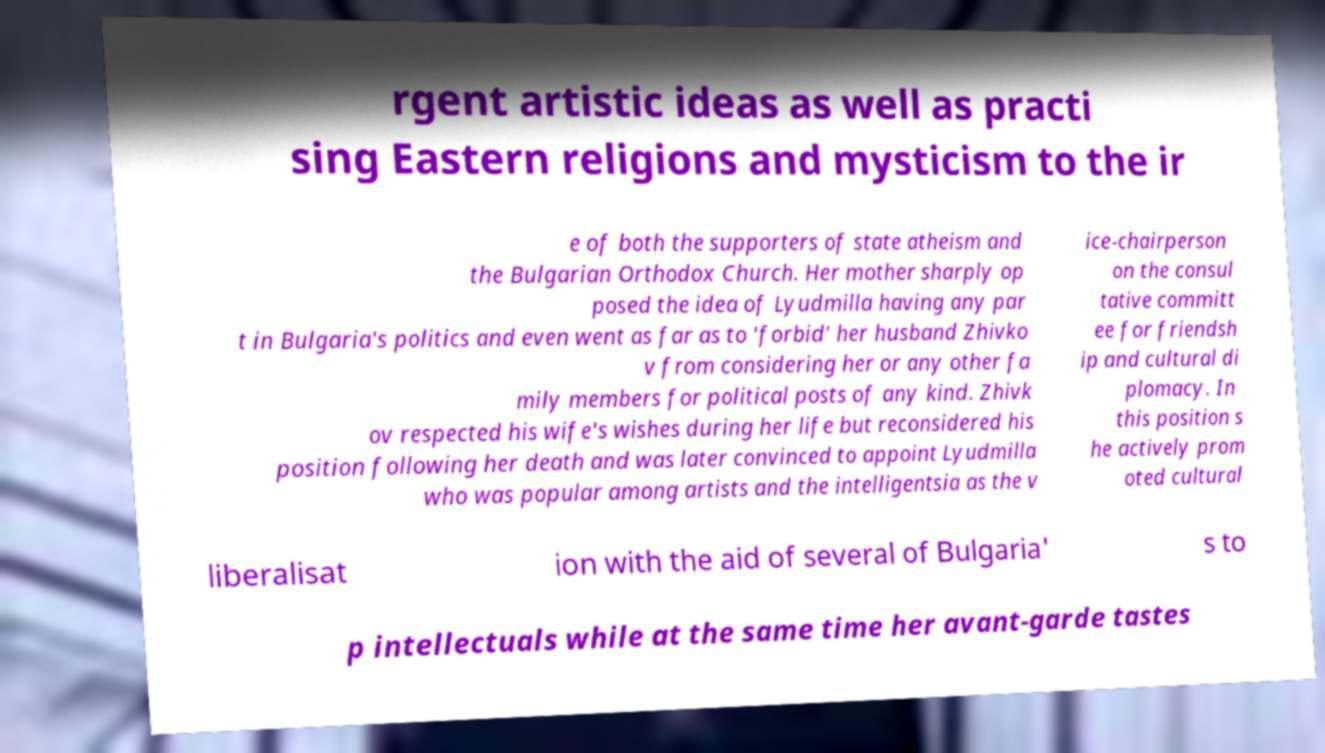There's text embedded in this image that I need extracted. Can you transcribe it verbatim? rgent artistic ideas as well as practi sing Eastern religions and mysticism to the ir e of both the supporters of state atheism and the Bulgarian Orthodox Church. Her mother sharply op posed the idea of Lyudmilla having any par t in Bulgaria's politics and even went as far as to 'forbid' her husband Zhivko v from considering her or any other fa mily members for political posts of any kind. Zhivk ov respected his wife's wishes during her life but reconsidered his position following her death and was later convinced to appoint Lyudmilla who was popular among artists and the intelligentsia as the v ice-chairperson on the consul tative committ ee for friendsh ip and cultural di plomacy. In this position s he actively prom oted cultural liberalisat ion with the aid of several of Bulgaria' s to p intellectuals while at the same time her avant-garde tastes 